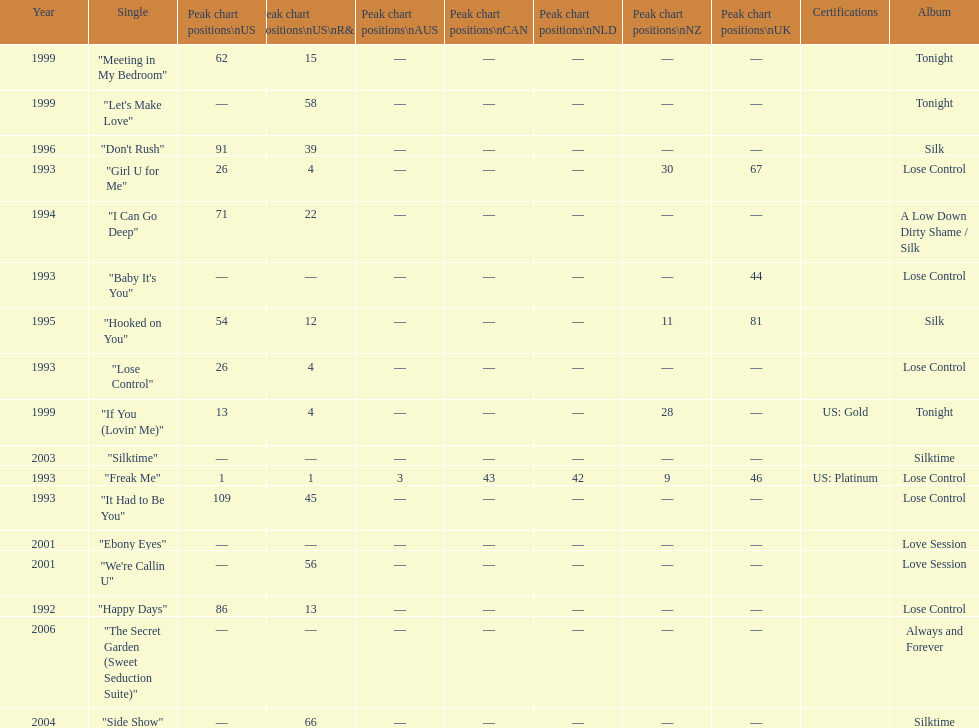Which single is the most in terms of how many times it charted? "Freak Me". 